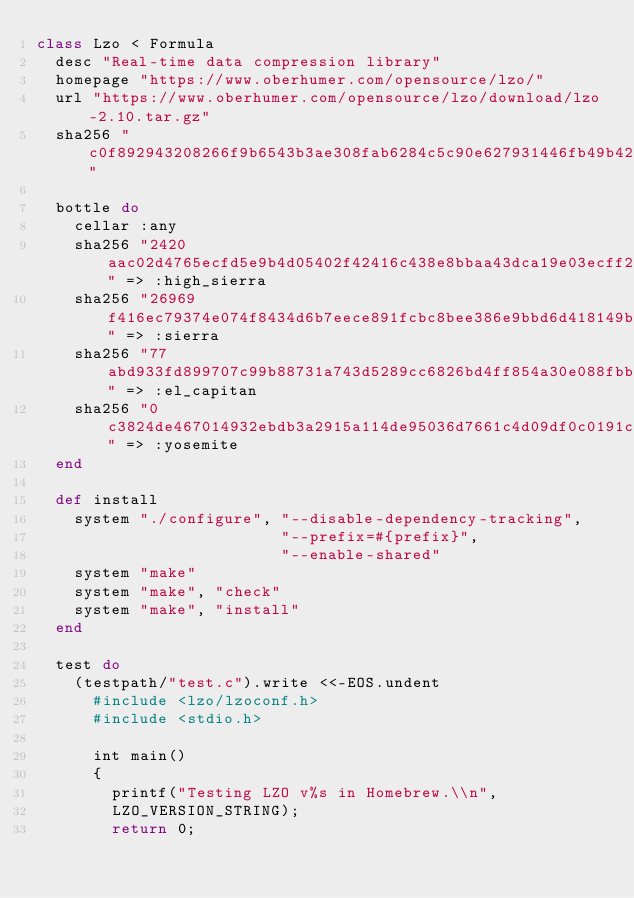Convert code to text. <code><loc_0><loc_0><loc_500><loc_500><_Ruby_>class Lzo < Formula
  desc "Real-time data compression library"
  homepage "https://www.oberhumer.com/opensource/lzo/"
  url "https://www.oberhumer.com/opensource/lzo/download/lzo-2.10.tar.gz"
  sha256 "c0f892943208266f9b6543b3ae308fab6284c5c90e627931446fb49b4221a072"

  bottle do
    cellar :any
    sha256 "2420aac02d4765ecfd5e9b4d05402f42416c438e8bbaa43dca19e03ecff2a670" => :high_sierra
    sha256 "26969f416ec79374e074f8434d6b7eece891fcbc8bee386e9bbd6d418149bc52" => :sierra
    sha256 "77abd933fd899707c99b88731a743d5289cc6826bd4ff854a30e088fbbc61222" => :el_capitan
    sha256 "0c3824de467014932ebdb3a2915a114de95036d7661c4d09df0c0191c9149e22" => :yosemite
  end

  def install
    system "./configure", "--disable-dependency-tracking",
                          "--prefix=#{prefix}",
                          "--enable-shared"
    system "make"
    system "make", "check"
    system "make", "install"
  end

  test do
    (testpath/"test.c").write <<-EOS.undent
      #include <lzo/lzoconf.h>
      #include <stdio.h>

      int main()
      {
        printf("Testing LZO v%s in Homebrew.\\n",
        LZO_VERSION_STRING);
        return 0;</code> 